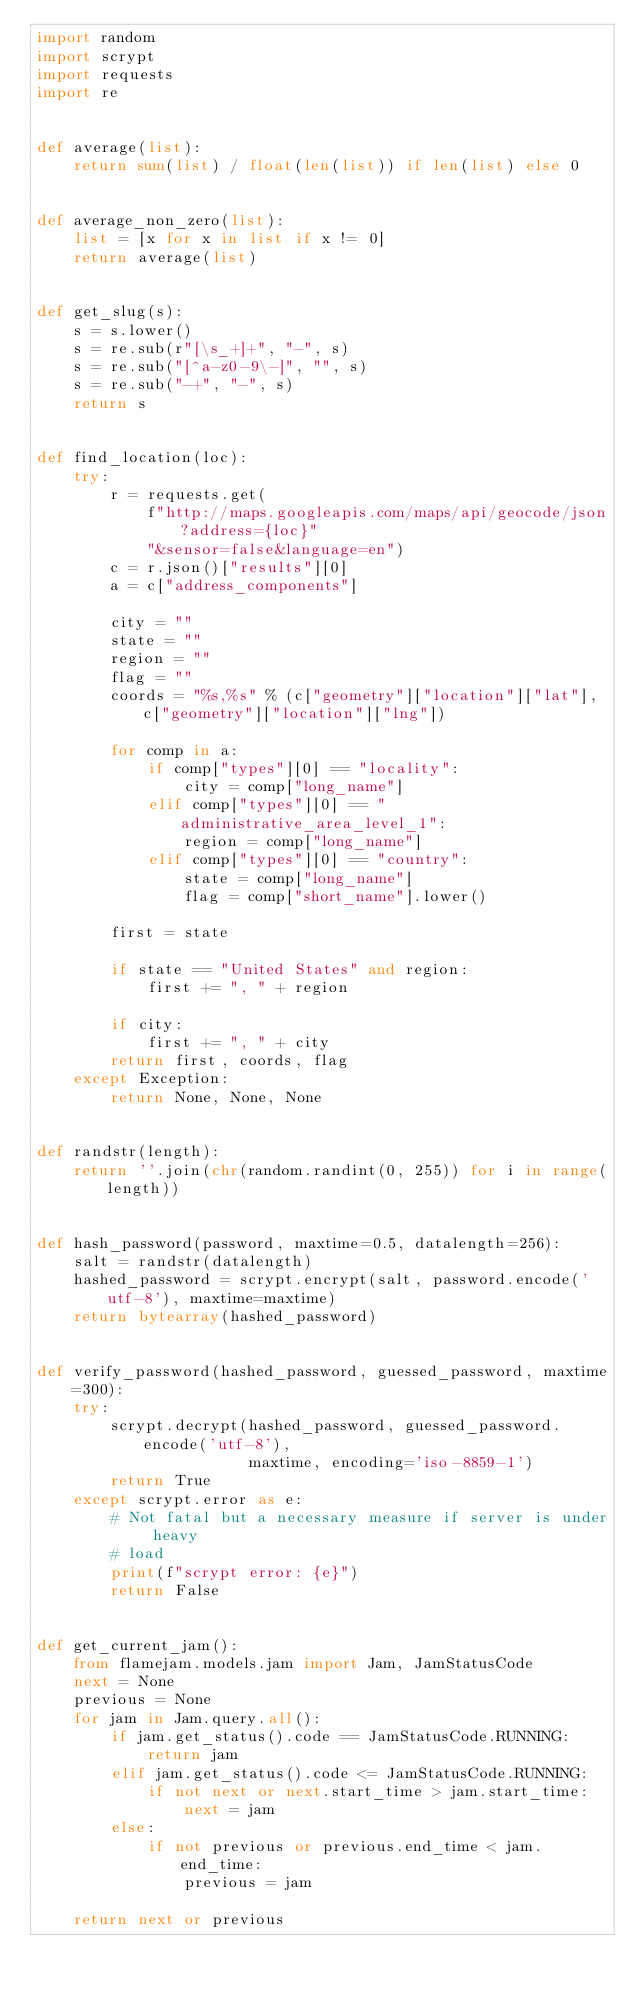<code> <loc_0><loc_0><loc_500><loc_500><_Python_>import random
import scrypt
import requests
import re


def average(list):
    return sum(list) / float(len(list)) if len(list) else 0


def average_non_zero(list):
    list = [x for x in list if x != 0]
    return average(list)


def get_slug(s):
    s = s.lower()
    s = re.sub(r"[\s_+]+", "-", s)
    s = re.sub("[^a-z0-9\-]", "", s)
    s = re.sub("-+", "-", s)
    return s


def find_location(loc):
    try:
        r = requests.get(
            f"http://maps.googleapis.com/maps/api/geocode/json?address={loc}"
            "&sensor=false&language=en")
        c = r.json()["results"][0]
        a = c["address_components"]

        city = ""
        state = ""
        region = ""
        flag = ""
        coords = "%s,%s" % (c["geometry"]["location"]["lat"], c["geometry"]["location"]["lng"])

        for comp in a:
            if comp["types"][0] == "locality":
                city = comp["long_name"]
            elif comp["types"][0] == "administrative_area_level_1":
                region = comp["long_name"]
            elif comp["types"][0] == "country":
                state = comp["long_name"]
                flag = comp["short_name"].lower()

        first = state

        if state == "United States" and region:
            first += ", " + region

        if city:
            first += ", " + city
        return first, coords, flag
    except Exception:
        return None, None, None


def randstr(length):
    return ''.join(chr(random.randint(0, 255)) for i in range(length))


def hash_password(password, maxtime=0.5, datalength=256):
    salt = randstr(datalength)
    hashed_password = scrypt.encrypt(salt, password.encode('utf-8'), maxtime=maxtime)
    return bytearray(hashed_password)


def verify_password(hashed_password, guessed_password, maxtime=300):
    try:
        scrypt.decrypt(hashed_password, guessed_password.encode('utf-8'),
                       maxtime, encoding='iso-8859-1')
        return True
    except scrypt.error as e:
        # Not fatal but a necessary measure if server is under heavy
        # load
        print(f"scrypt error: {e}")
        return False


def get_current_jam():
    from flamejam.models.jam import Jam, JamStatusCode
    next = None
    previous = None
    for jam in Jam.query.all():
        if jam.get_status().code == JamStatusCode.RUNNING:
            return jam
        elif jam.get_status().code <= JamStatusCode.RUNNING:
            if not next or next.start_time > jam.start_time:
                next = jam
        else:
            if not previous or previous.end_time < jam.end_time:
                previous = jam

    return next or previous
</code> 